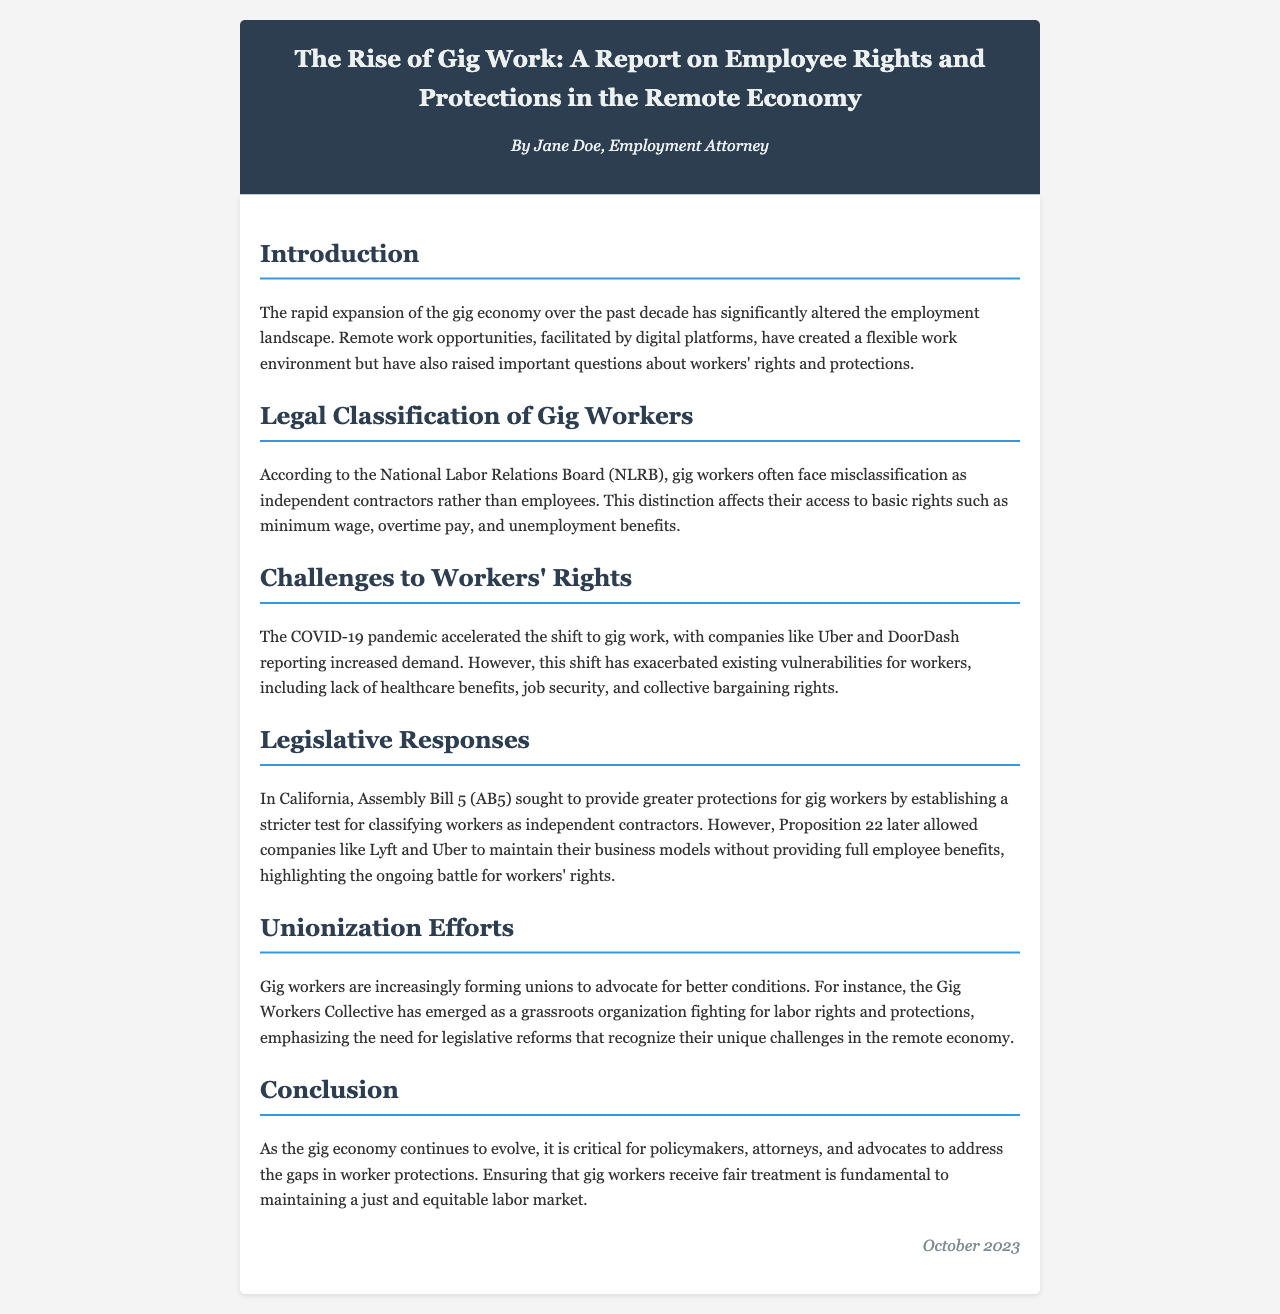What are gig workers often misclassified as? The report mentions that gig workers are often misclassified as independent contractors rather than employees.
Answer: independent contractors What law in California sought to provide greater protections for gig workers? The report references Assembly Bill 5 (AB5) as a law that aimed to provide more protections for gig workers.
Answer: Assembly Bill 5 (AB5) What organization has emerged to advocate for gig workers' rights? The Gig Workers Collective is identified in the report as an organization advocating for labor rights and protections.
Answer: Gig Workers Collective What issue has been exacerbated by the shift to gig work during the COVID-19 pandemic? The report states that vulnerabilities for workers, such as lack of healthcare benefits, have been exacerbated.
Answer: lack of healthcare benefits What is critical for policymakers according to the conclusion of the report? The conclusion emphasizes that addressing the gaps in worker protections is critical for policymakers.
Answer: addressing the gaps in worker protections What year was this report published? The document states that it was published in October 2023.
Answer: October 2023 